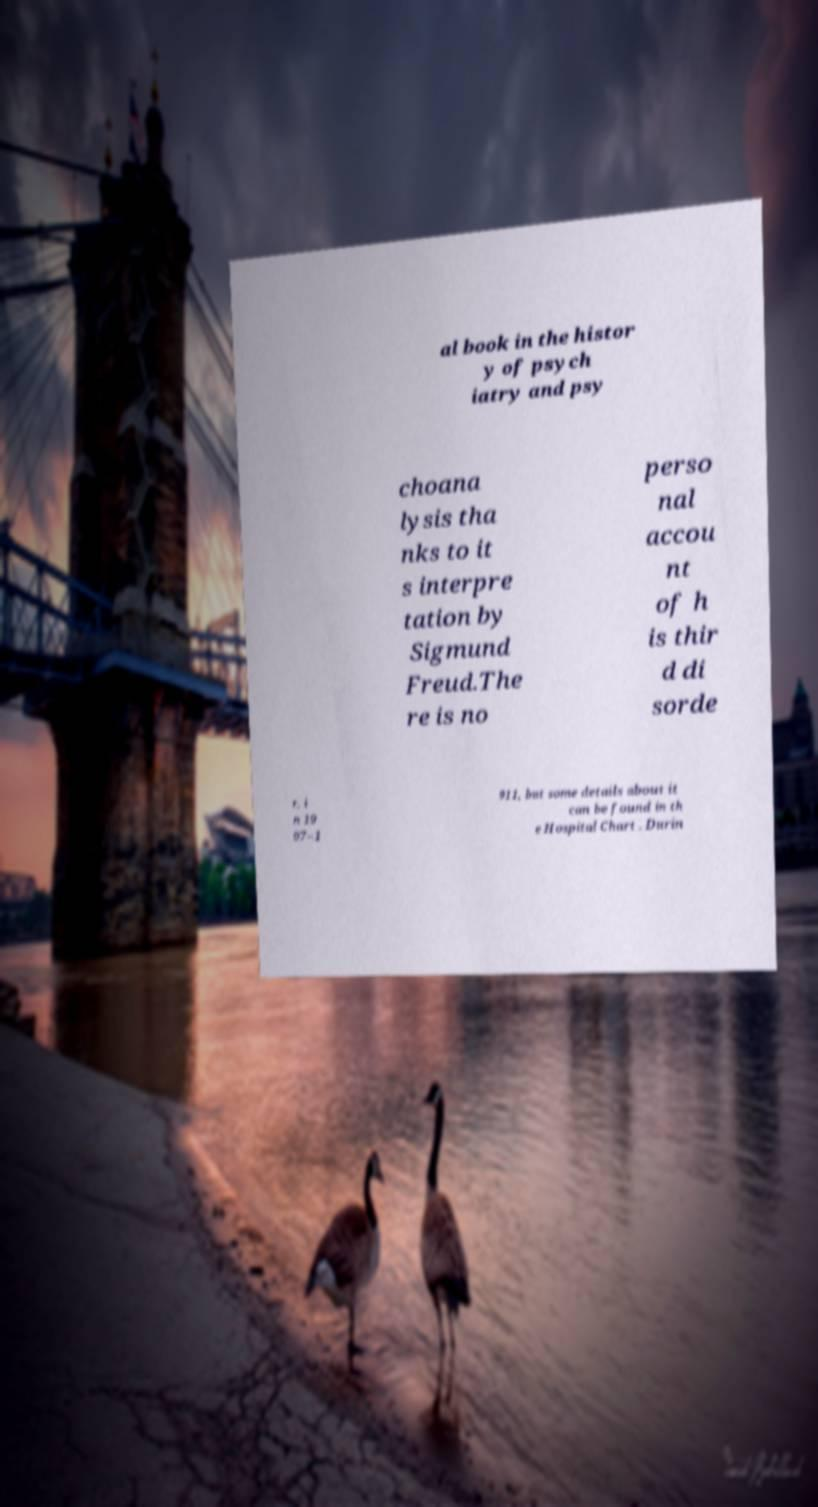Please read and relay the text visible in this image. What does it say? al book in the histor y of psych iatry and psy choana lysis tha nks to it s interpre tation by Sigmund Freud.The re is no perso nal accou nt of h is thir d di sorde r, i n 19 07–1 911, but some details about it can be found in th e Hospital Chart . Durin 